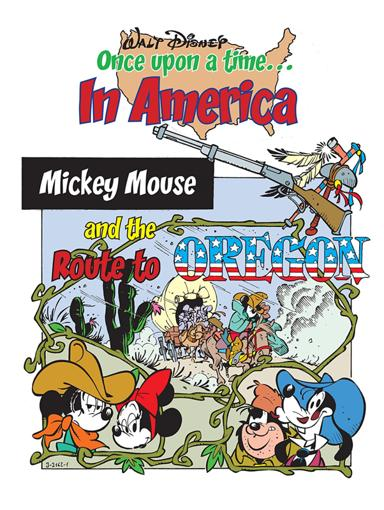What historical American period might this image be referencing, and how are the Disney characters integrated into that context? The image appears to reference the American pioneer era of westward expansion, specifically the Oregon Trail period. Disney characters such as Mickey, Minnie, and Goofy are integrated in a humorous yet historically themed fashion, portraying them as pioneers exploring and settling the American West. 